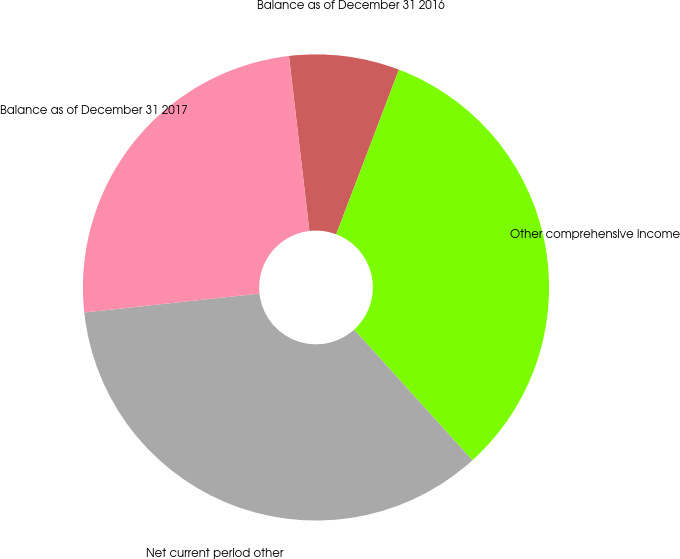Convert chart to OTSL. <chart><loc_0><loc_0><loc_500><loc_500><pie_chart><fcel>Balance as of December 31 2016<fcel>Other comprehensive income<fcel>Net current period other<fcel>Balance as of December 31 2017<nl><fcel>7.64%<fcel>32.5%<fcel>34.99%<fcel>24.86%<nl></chart> 